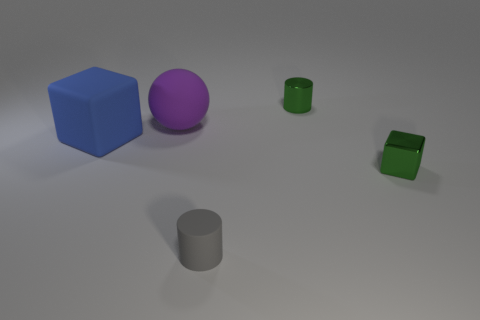Add 4 large gray things. How many objects exist? 9 Subtract all blocks. How many objects are left? 3 Subtract 0 blue spheres. How many objects are left? 5 Subtract all tiny green things. Subtract all rubber objects. How many objects are left? 0 Add 5 blue cubes. How many blue cubes are left? 6 Add 2 gray rubber objects. How many gray rubber objects exist? 3 